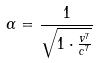Convert formula to latex. <formula><loc_0><loc_0><loc_500><loc_500>\alpha = \frac { 1 } { \sqrt { 1 \cdot \frac { v ^ { 7 } } { c ^ { 7 } } } }</formula> 